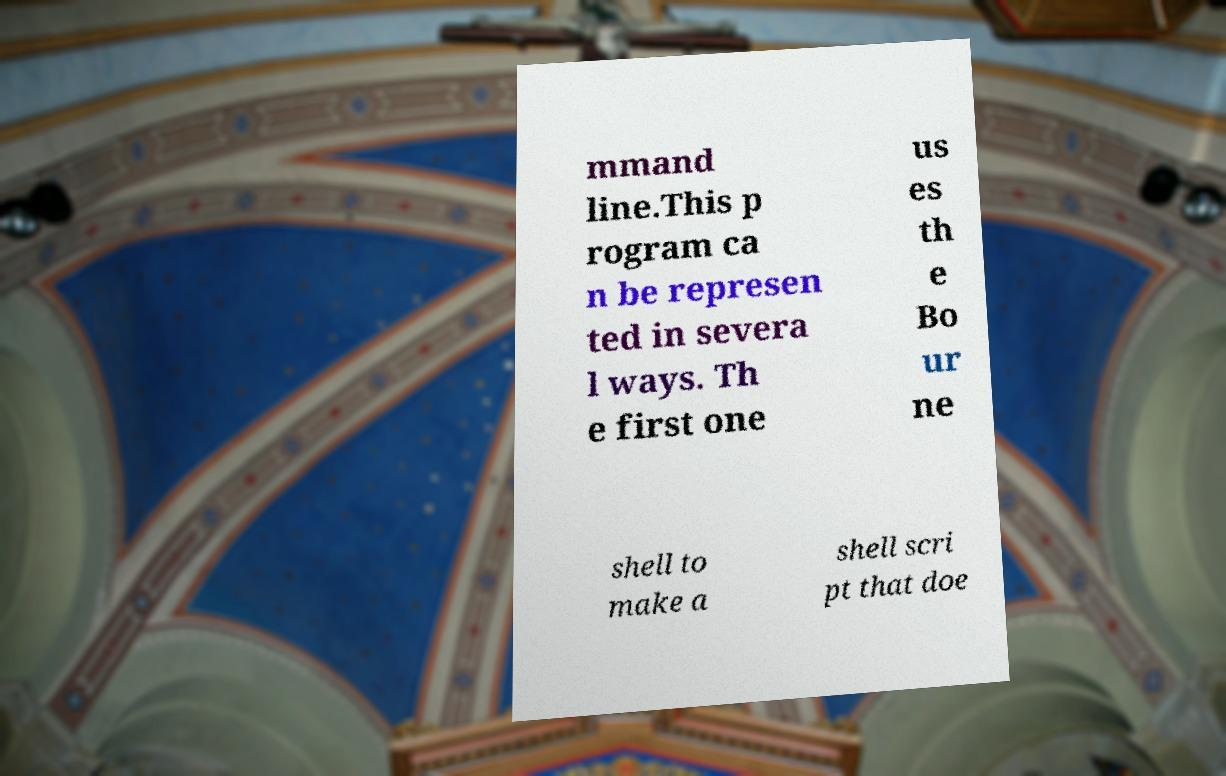Could you extract and type out the text from this image? mmand line.This p rogram ca n be represen ted in severa l ways. Th e first one us es th e Bo ur ne shell to make a shell scri pt that doe 